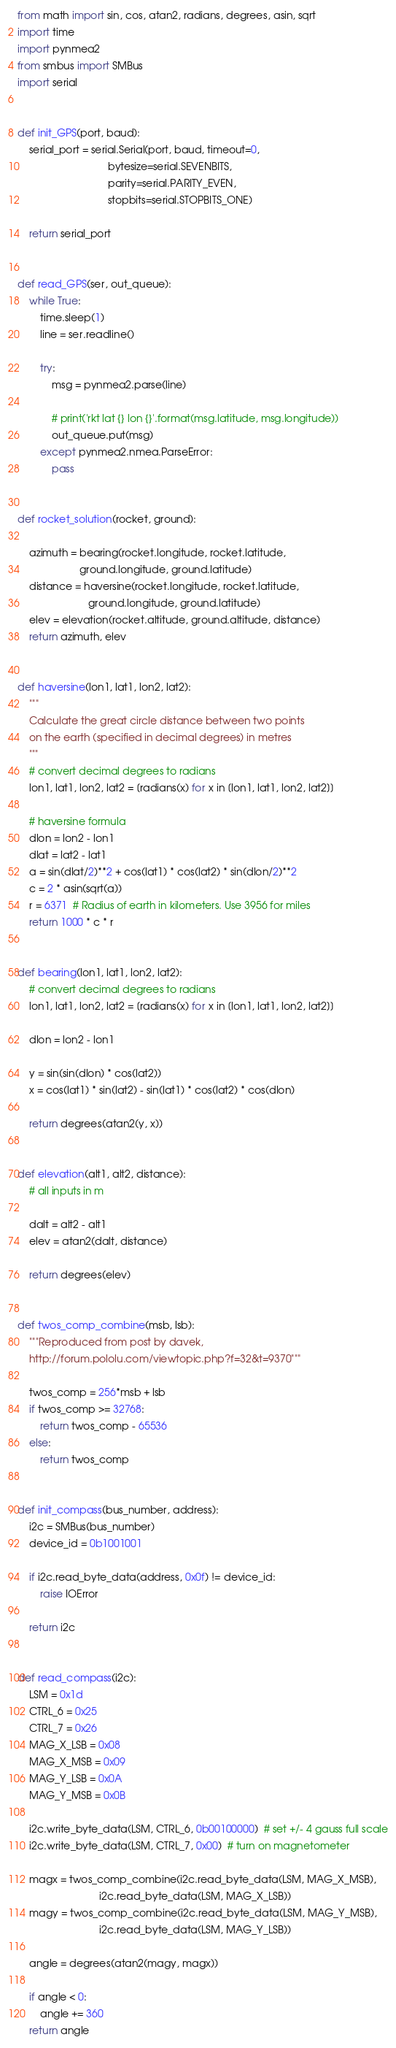Convert code to text. <code><loc_0><loc_0><loc_500><loc_500><_Python_>from math import sin, cos, atan2, radians, degrees, asin, sqrt
import time
import pynmea2
from smbus import SMBus
import serial


def init_GPS(port, baud):
    serial_port = serial.Serial(port, baud, timeout=0,
                                bytesize=serial.SEVENBITS,
                                parity=serial.PARITY_EVEN,
                                stopbits=serial.STOPBITS_ONE)

    return serial_port


def read_GPS(ser, out_queue):
    while True:
        time.sleep(1)
        line = ser.readline()

        try:
            msg = pynmea2.parse(line)

            # print('rkt lat {} lon {}'.format(msg.latitude, msg.longitude))
            out_queue.put(msg)
        except pynmea2.nmea.ParseError:
            pass


def rocket_solution(rocket, ground):

    azimuth = bearing(rocket.longitude, rocket.latitude,
                      ground.longitude, ground.latitude)
    distance = haversine(rocket.longitude, rocket.latitude,
                         ground.longitude, ground.latitude)
    elev = elevation(rocket.altitude, ground.altitude, distance)
    return azimuth, elev


def haversine(lon1, lat1, lon2, lat2):
    """
    Calculate the great circle distance between two points
    on the earth (specified in decimal degrees) in metres
    """
    # convert decimal degrees to radians
    lon1, lat1, lon2, lat2 = [radians(x) for x in [lon1, lat1, lon2, lat2]]

    # haversine formula
    dlon = lon2 - lon1
    dlat = lat2 - lat1
    a = sin(dlat/2)**2 + cos(lat1) * cos(lat2) * sin(dlon/2)**2
    c = 2 * asin(sqrt(a))
    r = 6371  # Radius of earth in kilometers. Use 3956 for miles
    return 1000 * c * r


def bearing(lon1, lat1, lon2, lat2):
    # convert decimal degrees to radians
    lon1, lat1, lon2, lat2 = [radians(x) for x in [lon1, lat1, lon2, lat2]]

    dlon = lon2 - lon1

    y = sin(sin(dlon) * cos(lat2))
    x = cos(lat1) * sin(lat2) - sin(lat1) * cos(lat2) * cos(dlon)

    return degrees(atan2(y, x))


def elevation(alt1, alt2, distance):
    # all inputs in m

    dalt = alt2 - alt1
    elev = atan2(dalt, distance)

    return degrees(elev)


def twos_comp_combine(msb, lsb):
    """Reproduced from post by davek,
    http://forum.pololu.com/viewtopic.php?f=32&t=9370"""

    twos_comp = 256*msb + lsb
    if twos_comp >= 32768:
        return twos_comp - 65536
    else:
        return twos_comp


def init_compass(bus_number, address):
    i2c = SMBus(bus_number)
    device_id = 0b1001001

    if i2c.read_byte_data(address, 0x0f) != device_id:
        raise IOError

    return i2c


def read_compass(i2c):
    LSM = 0x1d
    CTRL_6 = 0x25
    CTRL_7 = 0x26
    MAG_X_LSB = 0x08
    MAG_X_MSB = 0x09
    MAG_Y_LSB = 0x0A
    MAG_Y_MSB = 0x0B

    i2c.write_byte_data(LSM, CTRL_6, 0b00100000)  # set +/- 4 gauss full scale
    i2c.write_byte_data(LSM, CTRL_7, 0x00)  # turn on magnetometer

    magx = twos_comp_combine(i2c.read_byte_data(LSM, MAG_X_MSB),
                             i2c.read_byte_data(LSM, MAG_X_LSB))
    magy = twos_comp_combine(i2c.read_byte_data(LSM, MAG_Y_MSB),
                             i2c.read_byte_data(LSM, MAG_Y_LSB))

    angle = degrees(atan2(magy, magx))

    if angle < 0:
        angle += 360
    return angle
</code> 